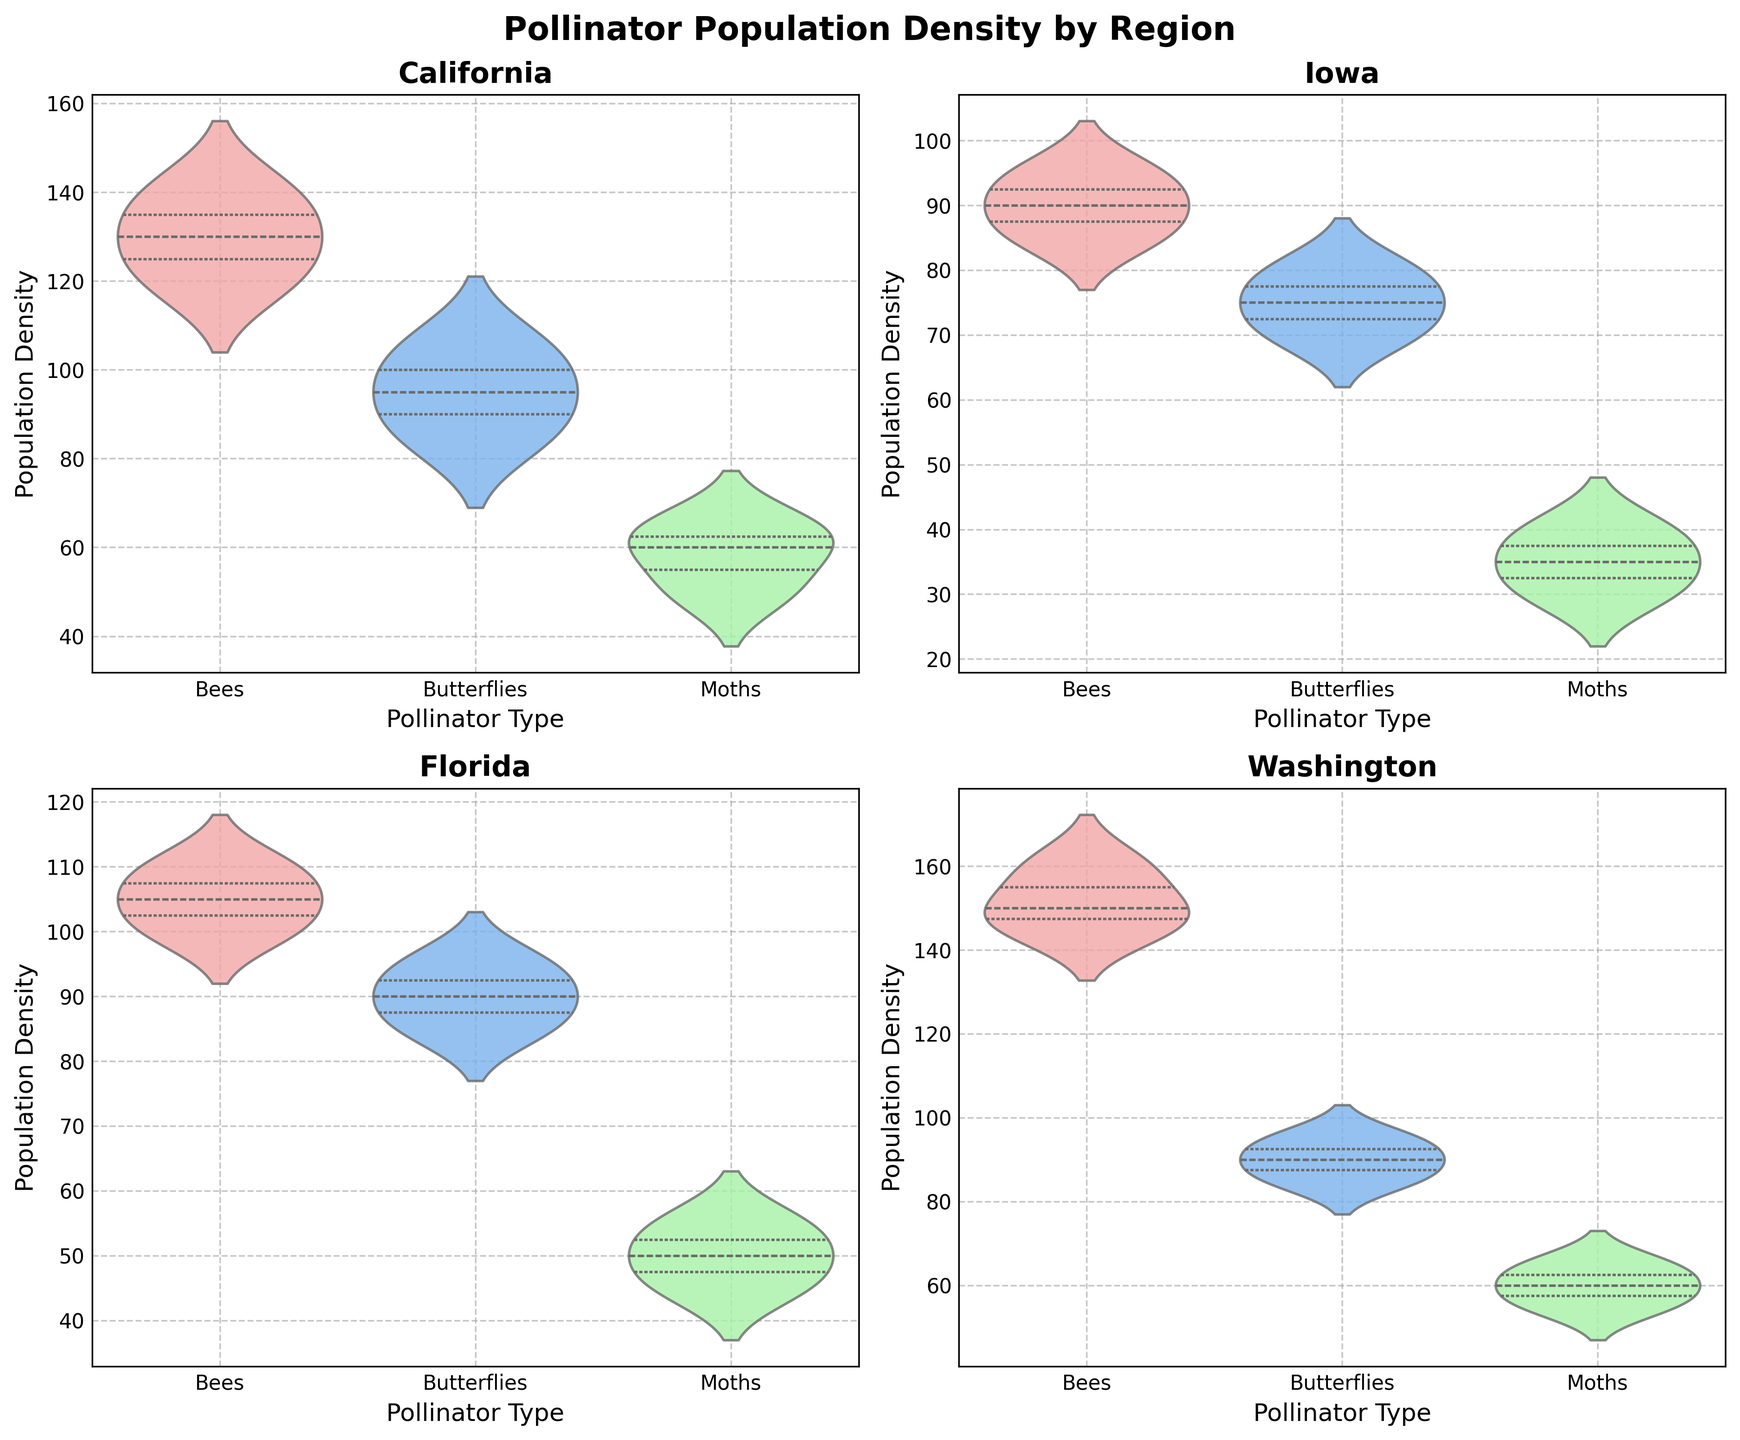Which region has the highest median population density for bees? By inspecting the violin plots for bees in each region, Washington shows the highest median population density as the solid white dot within the violin plot appears at the highest y-value compared to other regions.
Answer: Washington Which pollinator type in Iowa has the lowest median population density? Looking at the violin plots for Iowa, the moths have the lowest median population density indicated by the lowest position of the white dot inside the violin plot.
Answer: Moths What is the spread of the population density for butterflies in California? Examining the violin plot for butterflies in California, the spread (range) can be observed from approximately 85 to 105 on the y-axis, showing the density extends between these values.
Answer: 85 to 105 Among the regions shown, which one exhibits the smallest spread in population density for moths? By comparing the spreads of the violin plots for moths in all regions, Iowa shows the smallest spread, with densities ranging approximately from 30 to 40.
Answer: Iowa Between California and Florida, which region has a higher median population density for butterflies? Comparing the white dots within the violin plots for butterflies in California and Florida, California has a higher median population density, indicated by a higher position on the y-axis.
Answer: California 